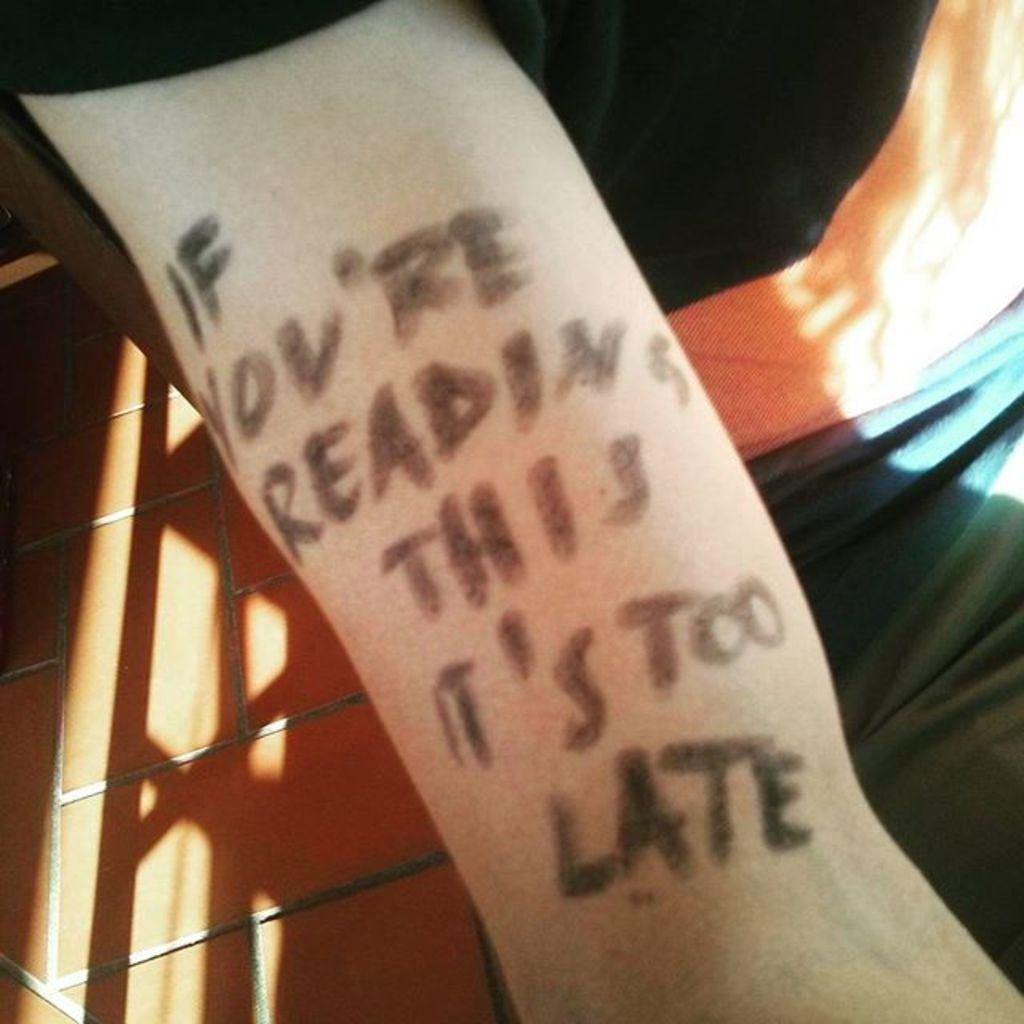What is the main subject of the image? There is a person in the image. What can be seen in the person's hand? The person's hand contains some text. What type of meal is being prepared in the image? There is no meal preparation visible in the image; it only shows a person with text in their hand. How is the light source affecting the image? There is no information about a light source in the image, as it only shows a person with text in their hand. 